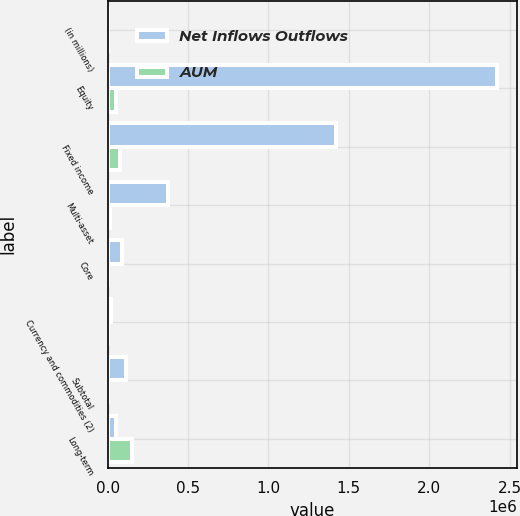Convert chart to OTSL. <chart><loc_0><loc_0><loc_500><loc_500><stacked_bar_chart><ecel><fcel>(in millions)<fcel>Equity<fcel>Fixed income<fcel>Multi-asset<fcel>Core<fcel>Currency and commodities (2)<fcel>Subtotal<fcel>Long-term<nl><fcel>Net Inflows Outflows<fcel>2015<fcel>2.42377e+06<fcel>1.42237e+06<fcel>376336<fcel>92085<fcel>20754<fcel>112839<fcel>52778<nl><fcel>AUM<fcel>2015<fcel>52778<fcel>76944<fcel>17167<fcel>4080<fcel>1045<fcel>5125<fcel>152014<nl></chart> 